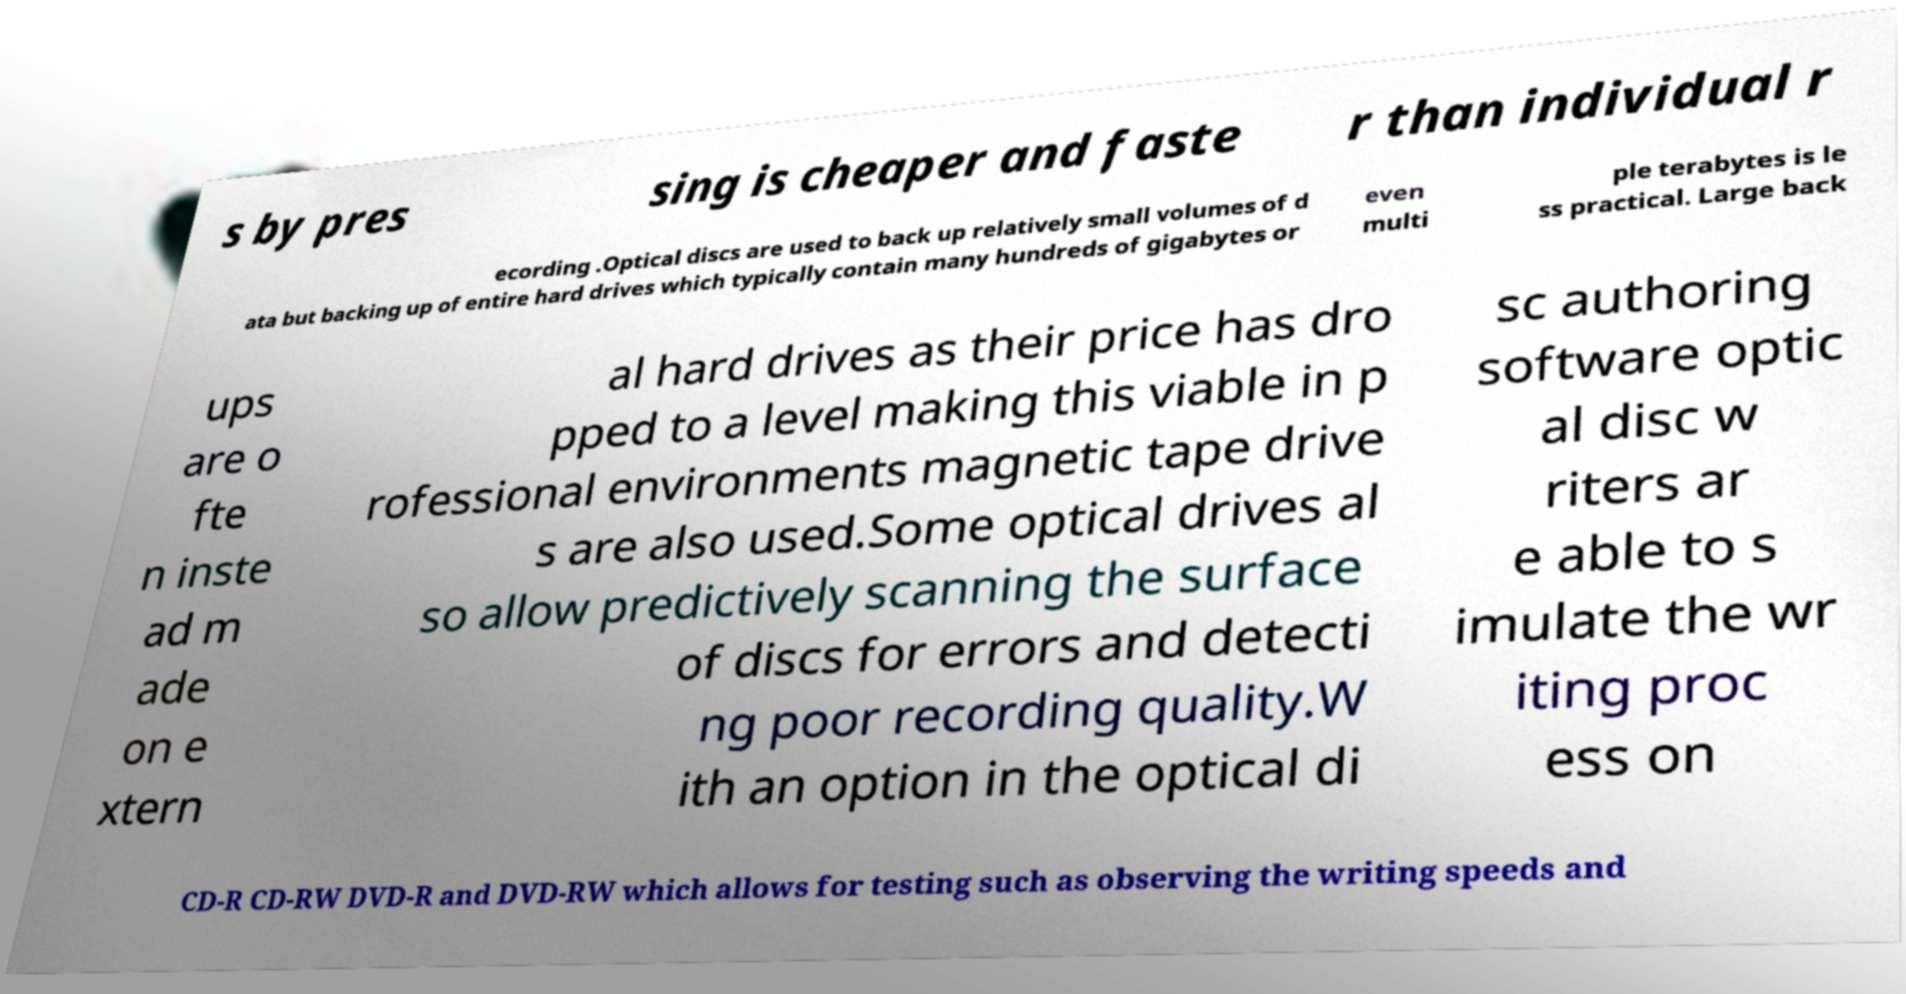There's text embedded in this image that I need extracted. Can you transcribe it verbatim? s by pres sing is cheaper and faste r than individual r ecording .Optical discs are used to back up relatively small volumes of d ata but backing up of entire hard drives which typically contain many hundreds of gigabytes or even multi ple terabytes is le ss practical. Large back ups are o fte n inste ad m ade on e xtern al hard drives as their price has dro pped to a level making this viable in p rofessional environments magnetic tape drive s are also used.Some optical drives al so allow predictively scanning the surface of discs for errors and detecti ng poor recording quality.W ith an option in the optical di sc authoring software optic al disc w riters ar e able to s imulate the wr iting proc ess on CD-R CD-RW DVD-R and DVD-RW which allows for testing such as observing the writing speeds and 